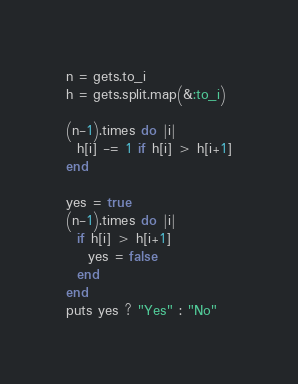<code> <loc_0><loc_0><loc_500><loc_500><_Ruby_>n = gets.to_i
h = gets.split.map(&:to_i)

(n-1).times do |i|
  h[i] -= 1 if h[i] > h[i+1]
end

yes = true
(n-1).times do |i|
  if h[i] > h[i+1]
    yes = false
  end
end
puts yes ? "Yes" : "No"</code> 